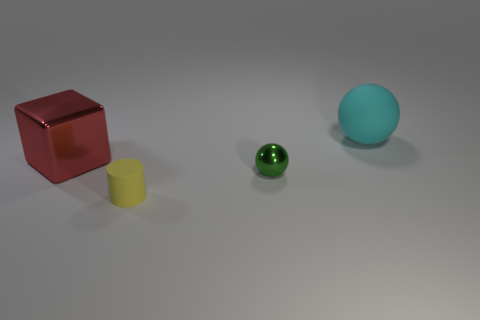How would you describe the arrangement of these objects? The objects are arranged in a diagonal line from the bottom left to the upper right of the image, spaced out with the cube and the larger sphere at the ends and the cylinders in between them. 